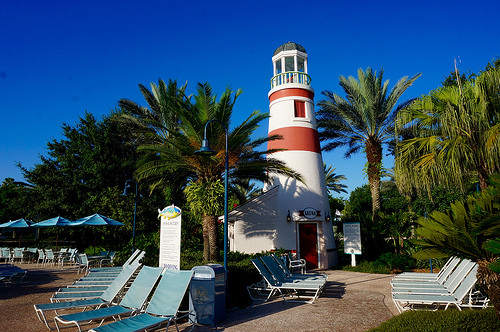<image>
Can you confirm if the sky is next to the lighthouse? No. The sky is not positioned next to the lighthouse. They are located in different areas of the scene. Is the lighthouse to the left of the palm tree? Yes. From this viewpoint, the lighthouse is positioned to the left side relative to the palm tree. 